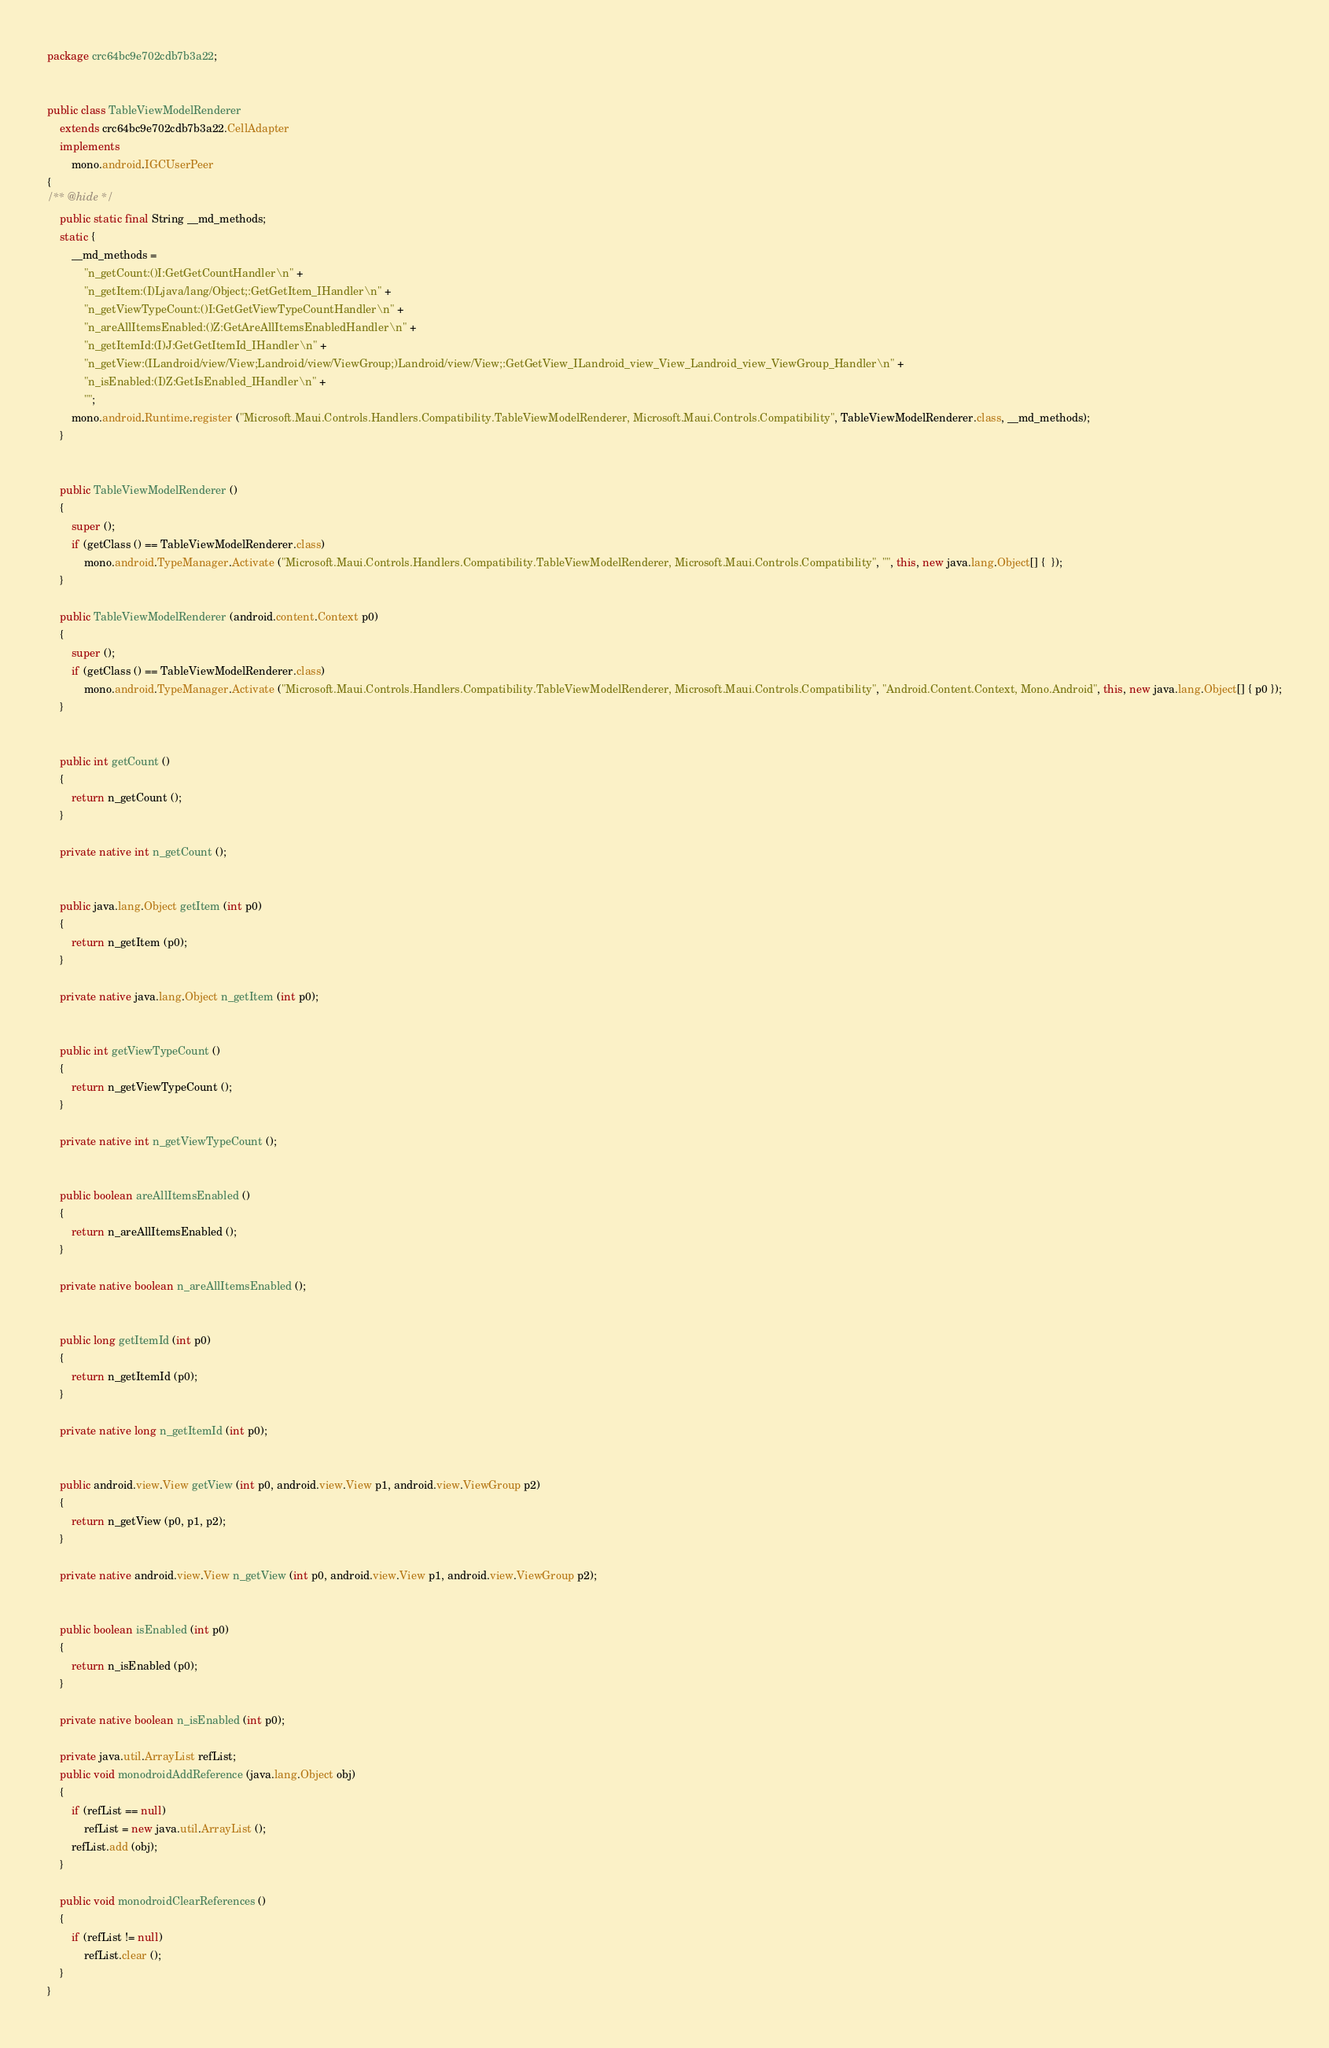<code> <loc_0><loc_0><loc_500><loc_500><_Java_>package crc64bc9e702cdb7b3a22;


public class TableViewModelRenderer
	extends crc64bc9e702cdb7b3a22.CellAdapter
	implements
		mono.android.IGCUserPeer
{
/** @hide */
	public static final String __md_methods;
	static {
		__md_methods = 
			"n_getCount:()I:GetGetCountHandler\n" +
			"n_getItem:(I)Ljava/lang/Object;:GetGetItem_IHandler\n" +
			"n_getViewTypeCount:()I:GetGetViewTypeCountHandler\n" +
			"n_areAllItemsEnabled:()Z:GetAreAllItemsEnabledHandler\n" +
			"n_getItemId:(I)J:GetGetItemId_IHandler\n" +
			"n_getView:(ILandroid/view/View;Landroid/view/ViewGroup;)Landroid/view/View;:GetGetView_ILandroid_view_View_Landroid_view_ViewGroup_Handler\n" +
			"n_isEnabled:(I)Z:GetIsEnabled_IHandler\n" +
			"";
		mono.android.Runtime.register ("Microsoft.Maui.Controls.Handlers.Compatibility.TableViewModelRenderer, Microsoft.Maui.Controls.Compatibility", TableViewModelRenderer.class, __md_methods);
	}


	public TableViewModelRenderer ()
	{
		super ();
		if (getClass () == TableViewModelRenderer.class)
			mono.android.TypeManager.Activate ("Microsoft.Maui.Controls.Handlers.Compatibility.TableViewModelRenderer, Microsoft.Maui.Controls.Compatibility", "", this, new java.lang.Object[] {  });
	}

	public TableViewModelRenderer (android.content.Context p0)
	{
		super ();
		if (getClass () == TableViewModelRenderer.class)
			mono.android.TypeManager.Activate ("Microsoft.Maui.Controls.Handlers.Compatibility.TableViewModelRenderer, Microsoft.Maui.Controls.Compatibility", "Android.Content.Context, Mono.Android", this, new java.lang.Object[] { p0 });
	}


	public int getCount ()
	{
		return n_getCount ();
	}

	private native int n_getCount ();


	public java.lang.Object getItem (int p0)
	{
		return n_getItem (p0);
	}

	private native java.lang.Object n_getItem (int p0);


	public int getViewTypeCount ()
	{
		return n_getViewTypeCount ();
	}

	private native int n_getViewTypeCount ();


	public boolean areAllItemsEnabled ()
	{
		return n_areAllItemsEnabled ();
	}

	private native boolean n_areAllItemsEnabled ();


	public long getItemId (int p0)
	{
		return n_getItemId (p0);
	}

	private native long n_getItemId (int p0);


	public android.view.View getView (int p0, android.view.View p1, android.view.ViewGroup p2)
	{
		return n_getView (p0, p1, p2);
	}

	private native android.view.View n_getView (int p0, android.view.View p1, android.view.ViewGroup p2);


	public boolean isEnabled (int p0)
	{
		return n_isEnabled (p0);
	}

	private native boolean n_isEnabled (int p0);

	private java.util.ArrayList refList;
	public void monodroidAddReference (java.lang.Object obj)
	{
		if (refList == null)
			refList = new java.util.ArrayList ();
		refList.add (obj);
	}

	public void monodroidClearReferences ()
	{
		if (refList != null)
			refList.clear ();
	}
}
</code> 